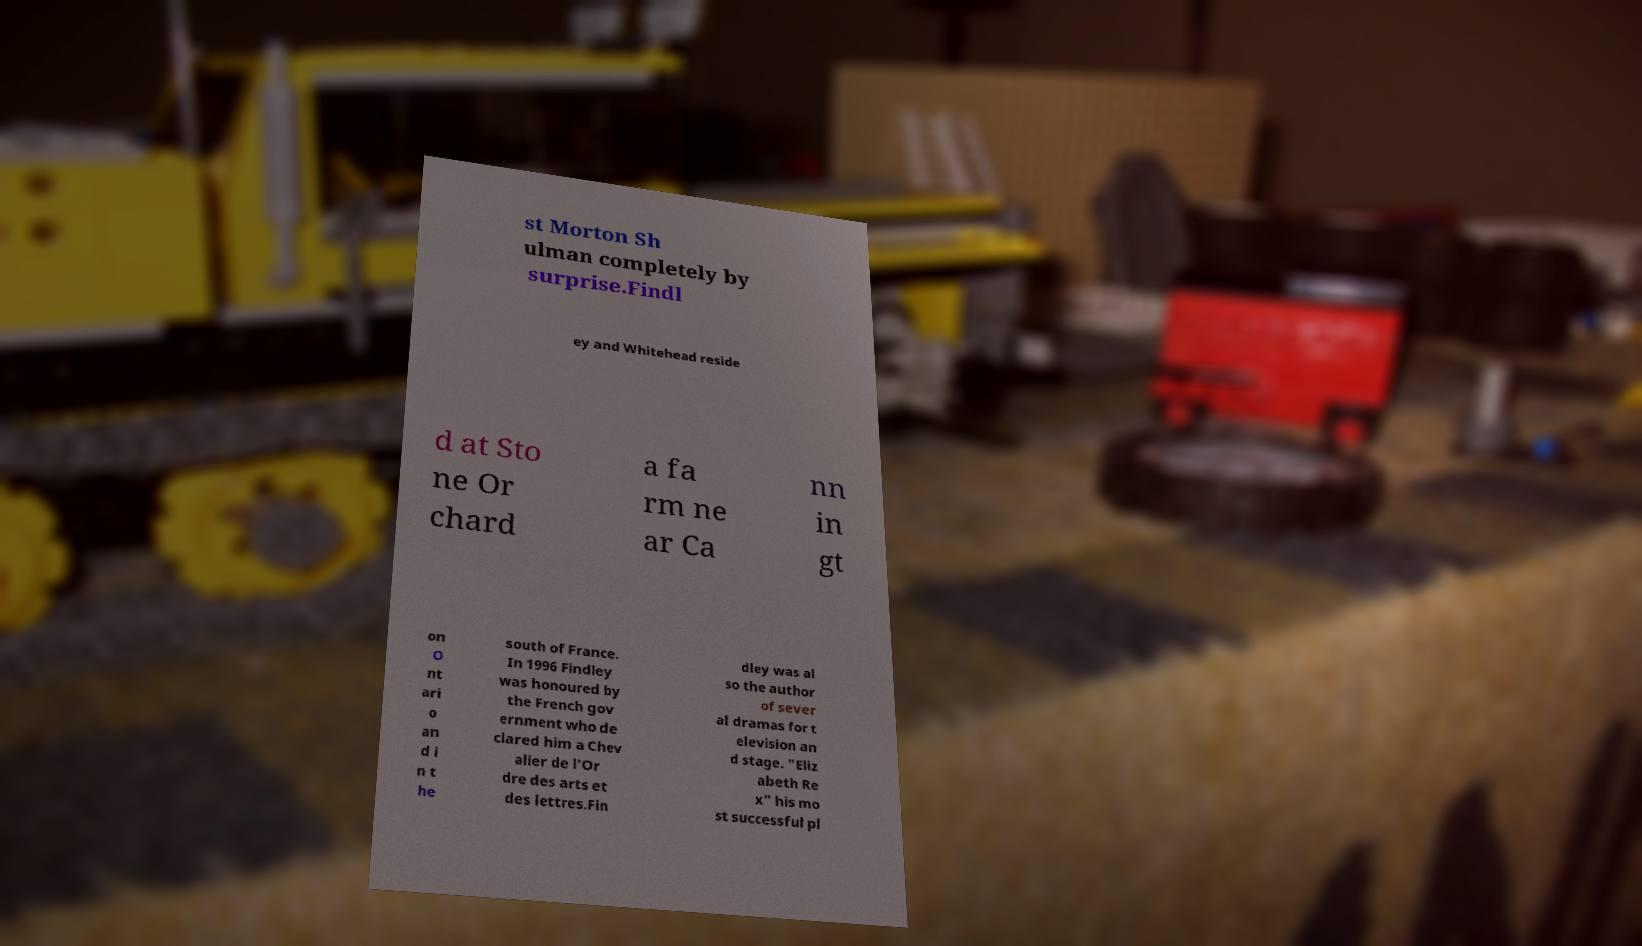Can you read and provide the text displayed in the image?This photo seems to have some interesting text. Can you extract and type it out for me? st Morton Sh ulman completely by surprise.Findl ey and Whitehead reside d at Sto ne Or chard a fa rm ne ar Ca nn in gt on O nt ari o an d i n t he south of France. In 1996 Findley was honoured by the French gov ernment who de clared him a Chev alier de l'Or dre des arts et des lettres.Fin dley was al so the author of sever al dramas for t elevision an d stage. "Eliz abeth Re x" his mo st successful pl 